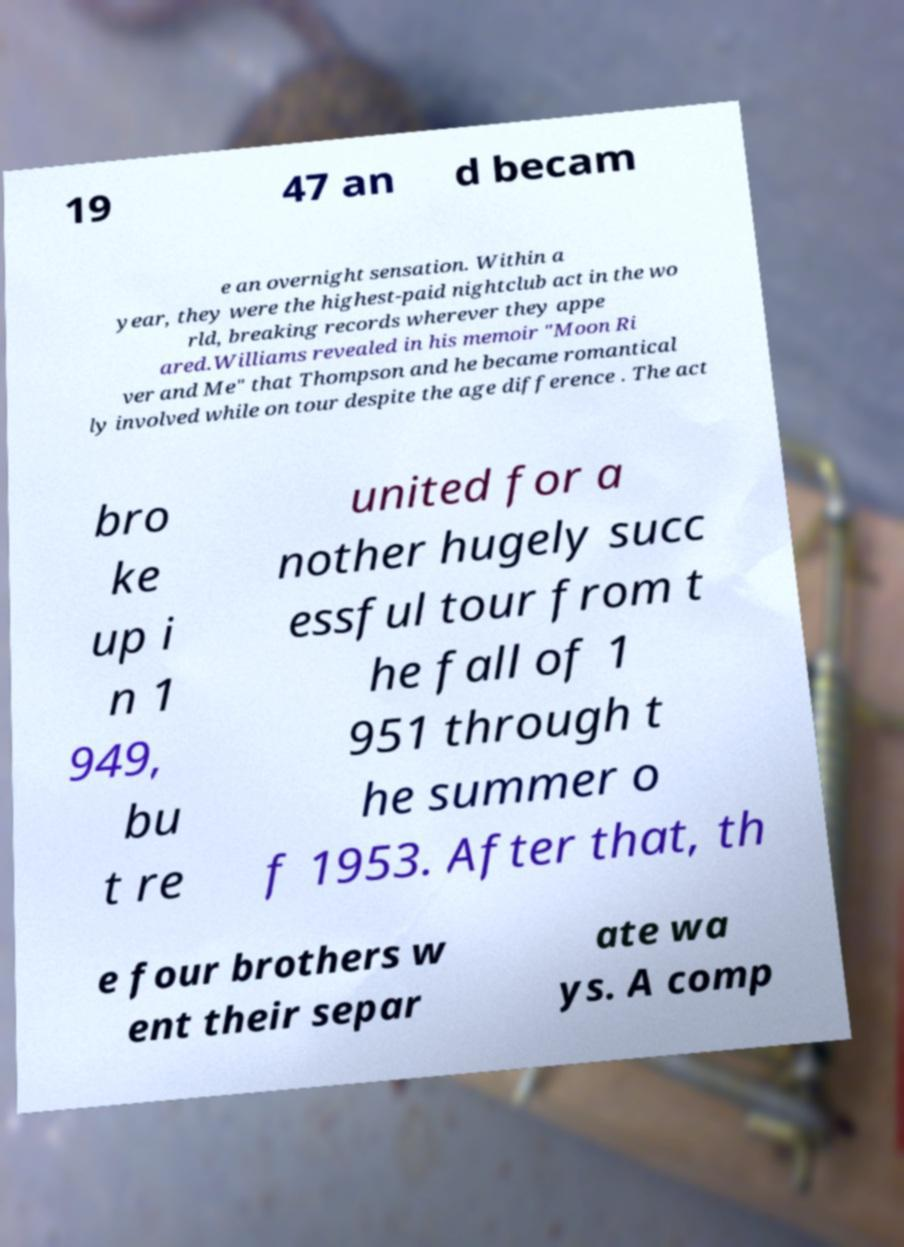Please read and relay the text visible in this image. What does it say? 19 47 an d becam e an overnight sensation. Within a year, they were the highest-paid nightclub act in the wo rld, breaking records wherever they appe ared.Williams revealed in his memoir "Moon Ri ver and Me" that Thompson and he became romantical ly involved while on tour despite the age difference . The act bro ke up i n 1 949, bu t re united for a nother hugely succ essful tour from t he fall of 1 951 through t he summer o f 1953. After that, th e four brothers w ent their separ ate wa ys. A comp 